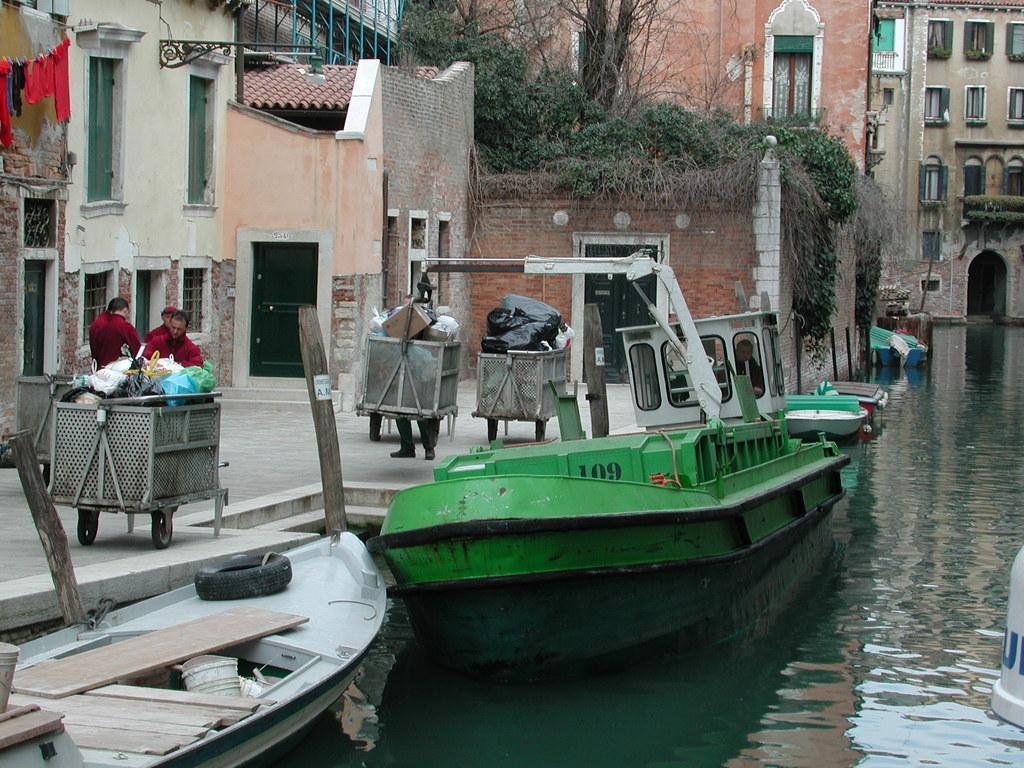Please provide a concise description of this image. This picture is clicked outside. In the foreground we can see the boats and some other objects in the water body. On the left we can see there are some objects in the carts and we can see the group of persons. In the background we can see the buildings and the clothes hanging on the rope and the trees. 